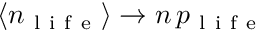Convert formula to latex. <formula><loc_0><loc_0><loc_500><loc_500>\langle n _ { l i f e } \rangle \rightarrow n \, p _ { l i f e }</formula> 